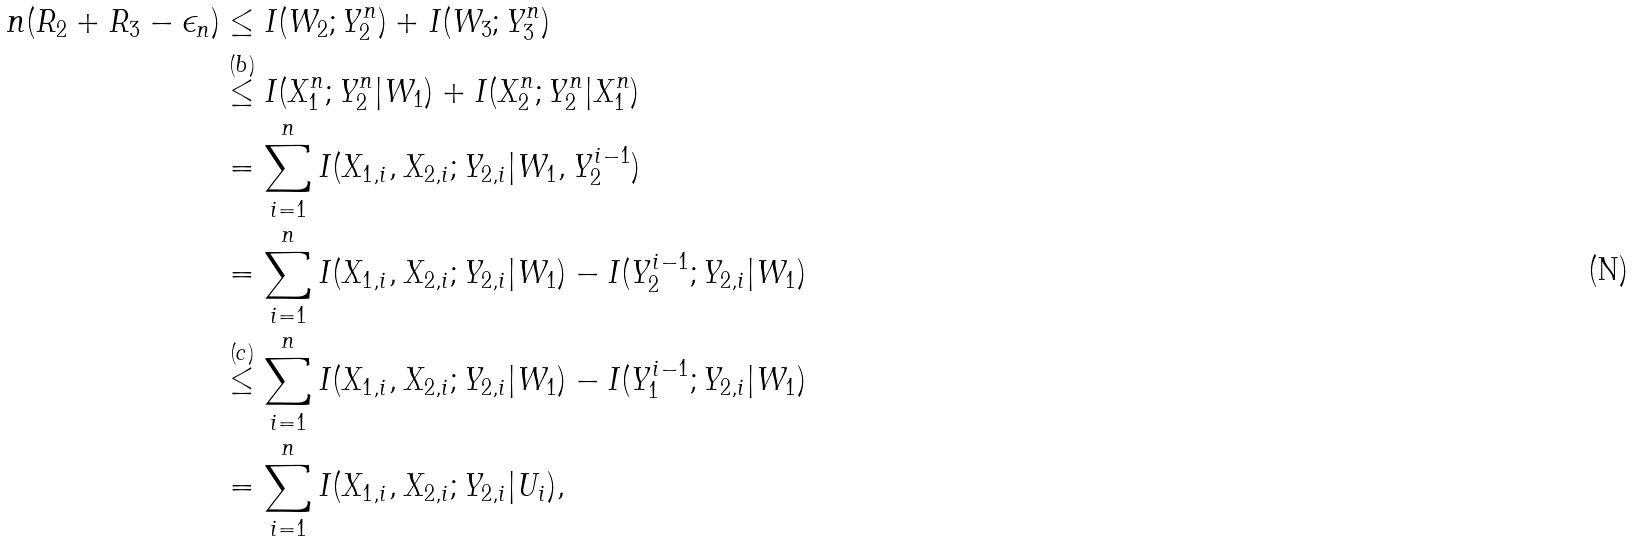<formula> <loc_0><loc_0><loc_500><loc_500>n ( R _ { 2 } + R _ { 3 } - \epsilon _ { n } ) & \leq I ( W _ { 2 } ; Y _ { 2 } ^ { n } ) + I ( W _ { 3 } ; Y _ { 3 } ^ { n } ) \\ & \overset { ( b ) } { \leq } I ( X _ { 1 } ^ { n } ; Y _ { 2 } ^ { n } | W _ { 1 } ) + I ( X _ { 2 } ^ { n } ; Y _ { 2 } ^ { n } | X _ { 1 } ^ { n } ) \\ & = \sum _ { i = 1 } ^ { n } I ( X _ { 1 , i } , X _ { 2 , i } ; Y _ { 2 , i } | W _ { 1 } , Y _ { 2 } ^ { i - 1 } ) \\ & = \sum _ { i = 1 } ^ { n } I ( X _ { 1 , i } , X _ { 2 , i } ; Y _ { 2 , i } | W _ { 1 } ) - I ( Y _ { 2 } ^ { i - 1 } ; Y _ { 2 , i } | W _ { 1 } ) \\ & \overset { ( c ) } { \leq } \sum _ { i = 1 } ^ { n } I ( X _ { 1 , i } , X _ { 2 , i } ; Y _ { 2 , i } | W _ { 1 } ) - I ( Y _ { 1 } ^ { i - 1 } ; Y _ { 2 , i } | W _ { 1 } ) \\ & = \sum _ { i = 1 } ^ { n } I ( X _ { 1 , i } , X _ { 2 , i } ; Y _ { 2 , i } | U _ { i } ) ,</formula> 